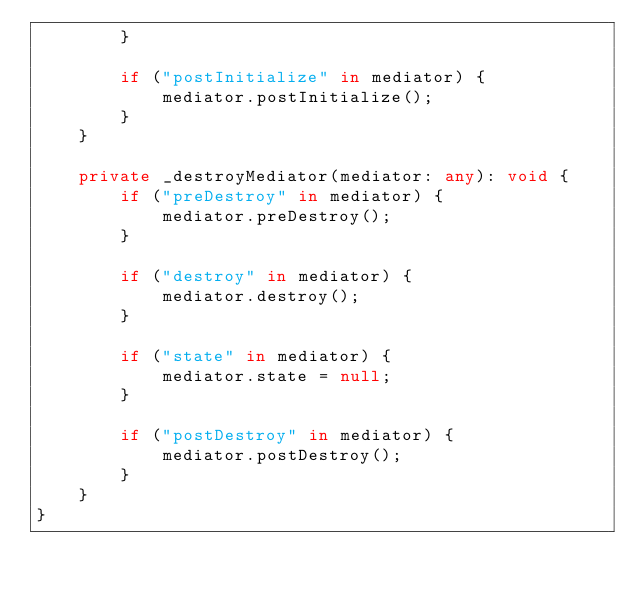<code> <loc_0><loc_0><loc_500><loc_500><_TypeScript_>        }

        if ("postInitialize" in mediator) {
            mediator.postInitialize();
        }
    }

    private _destroyMediator(mediator: any): void {
        if ("preDestroy" in mediator) {
            mediator.preDestroy();
        }

        if ("destroy" in mediator) {
            mediator.destroy();
        }

        if ("state" in mediator) {
            mediator.state = null;
        }

        if ("postDestroy" in mediator) {
            mediator.postDestroy();
        }
    }
}
</code> 